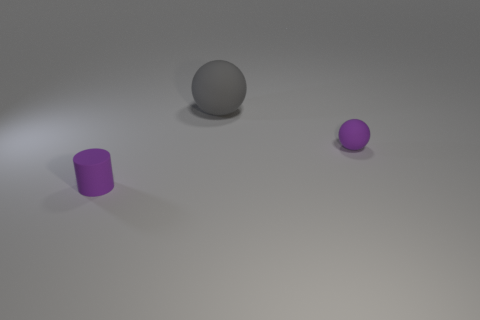Add 3 rubber cylinders. How many objects exist? 6 Subtract all balls. How many objects are left? 1 Add 1 small things. How many small things exist? 3 Subtract 1 gray balls. How many objects are left? 2 Subtract 1 cylinders. How many cylinders are left? 0 Subtract all brown spheres. Subtract all blue blocks. How many spheres are left? 2 Subtract all red blocks. How many gray spheres are left? 1 Subtract all big metallic blocks. Subtract all small rubber things. How many objects are left? 1 Add 1 tiny purple matte balls. How many tiny purple matte balls are left? 2 